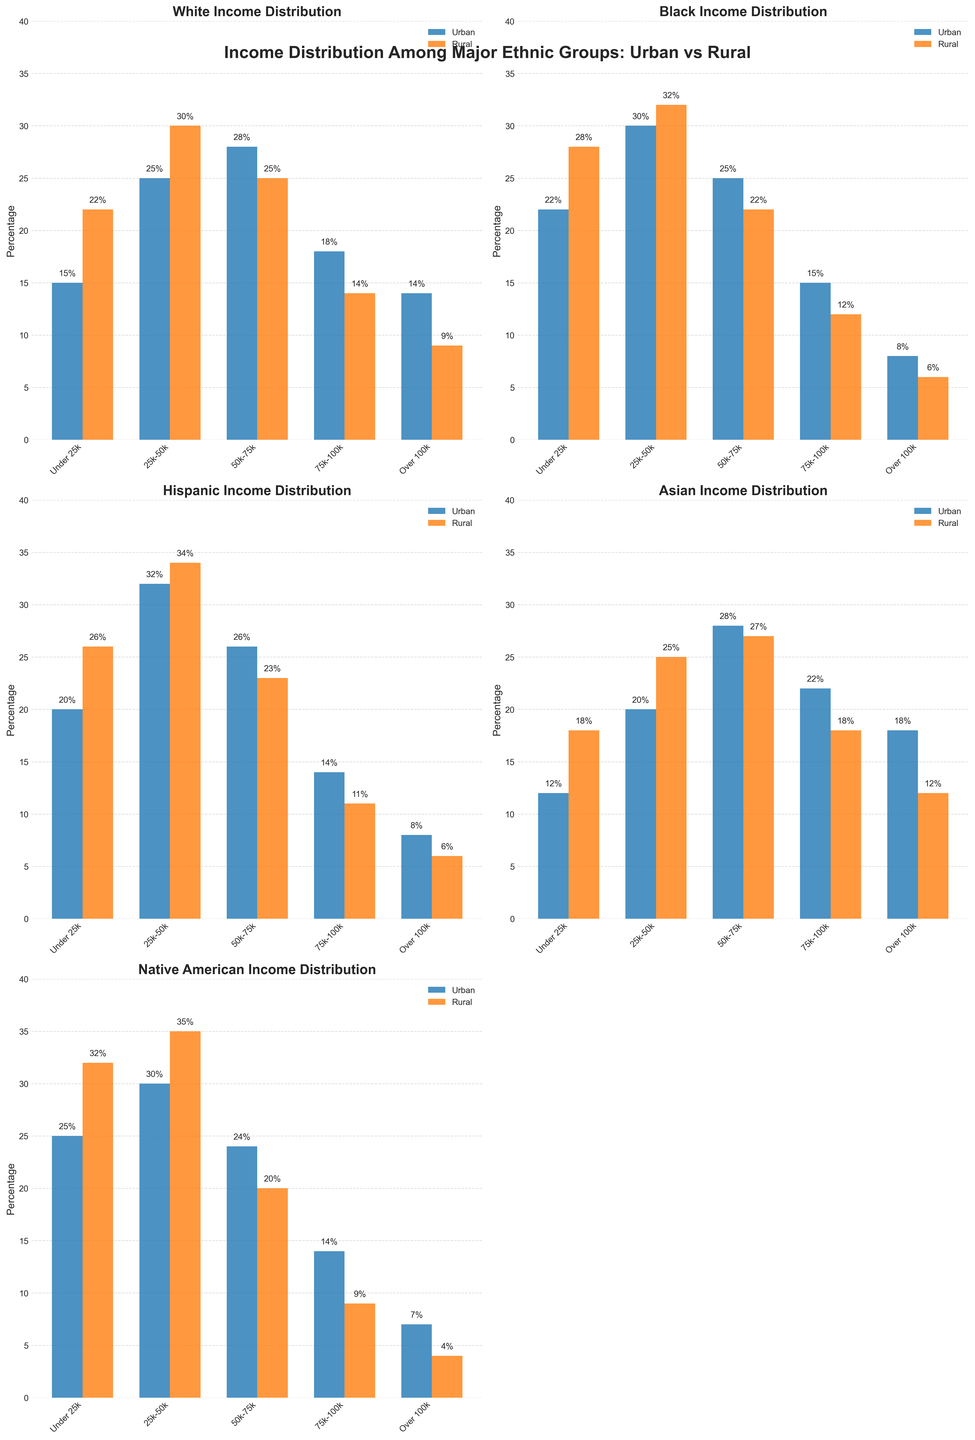What's the income bracket with the highest urban percentage for Whites? Look at the subplot titled 'White Income Distribution'. The tallest bar in the Urban category is for the '50k-75k' bracket.
Answer: 50k-75k Which ethnicity has the smallest difference in rural percentages for the 'Under 25k' income bracket? Look at all subplots and compare the rural bar heights for the 'Under 25k' bracket. Calculate the differences: White (7), Black (6), Hispanic (6), Asian (6), Native American (7).
Answer: Black, Hispanic, and Asian What is the combined rural percentage for the 'Over 100k' income bracket for Hispanics and Asians? Find the 'Over 100k' rural percentages in both 'Hispanic Income Distribution' and 'Asian Income Distribution' subplots. Add 6% (Hispanic) + 12% (Asian).
Answer: 18% Which ethnic group has the least urban percentage for the 'Under 25k' income bracket? Look at all subplots for the 'Under 25k' income bracket and identify the smallest urban bar. The percentages are White (15), Black (22), Hispanic (20), Asian (12), Native American (25).
Answer: Asian What is the difference in urban percentage between '25k-50k' and '75k-100k' for Black ethnicity? Find the percentages in the Black Income Distribution subplot: '25k-50k' (30%), '75k-100k' (15%). Subtract 15% from 30%.
Answer: 15% Compare and state which income bracket has a higher urban percentage for Asians: '75k-100k' or 'Over 100k'? Look at the 'Asian Income Distribution' subplot. The '75k-100k' urban percentage is 22%, and 'Over 100k' is 18%, so '75k-100k' has the higher percentage.
Answer: 75k-100k Which income bracket shows the highest rural percentage for Native Americans? Look at the 'Native American Income Distribution' subplot and identify the tallest bar in the Rural category, which is '25k-50k' at 35%.
Answer: 25k-50k How much greater is the 'Under 25k' rural percentage compared to the urban percentage for Hispanics? Find the percentages in the 'Hispanic Income Distribution' subplot: 'Under 25k' rural (26%), 'Under 25k' urban (20%). Subtract 20% from 26%.
Answer: 6% 